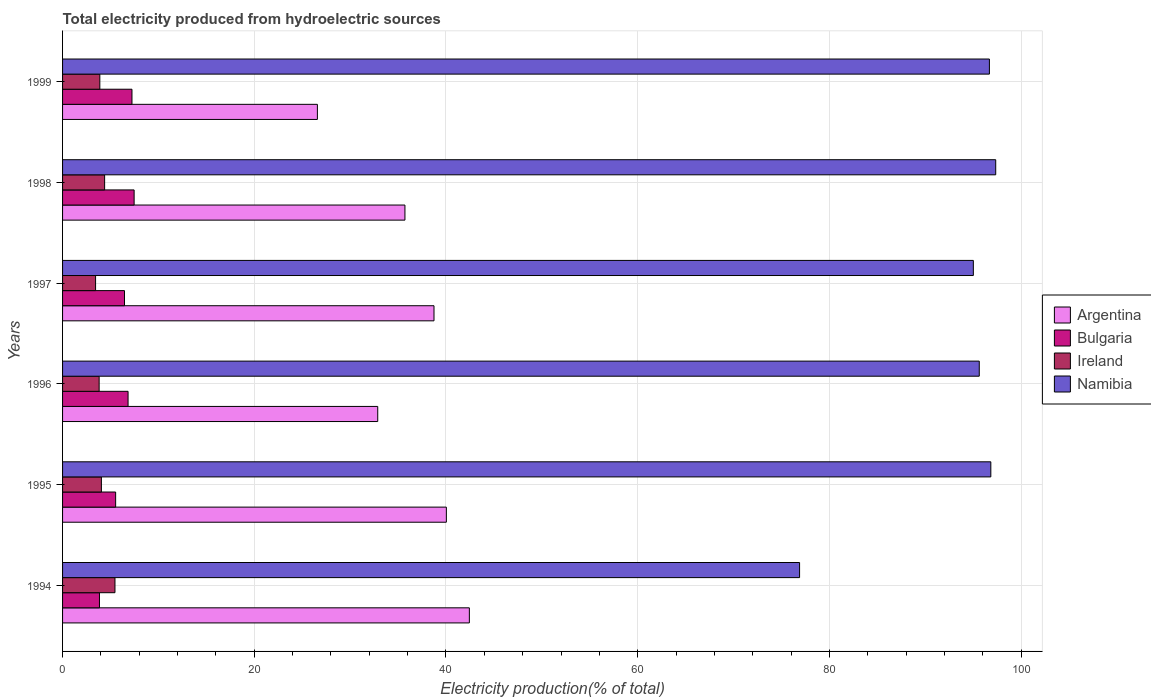How many different coloured bars are there?
Offer a very short reply. 4. How many groups of bars are there?
Your answer should be compact. 6. Are the number of bars on each tick of the Y-axis equal?
Your answer should be compact. Yes. How many bars are there on the 6th tick from the top?
Ensure brevity in your answer.  4. In how many cases, is the number of bars for a given year not equal to the number of legend labels?
Offer a very short reply. 0. What is the total electricity produced in Bulgaria in 1996?
Keep it short and to the point. 6.83. Across all years, what is the maximum total electricity produced in Argentina?
Your answer should be compact. 42.44. Across all years, what is the minimum total electricity produced in Ireland?
Offer a very short reply. 3.44. In which year was the total electricity produced in Argentina maximum?
Your response must be concise. 1994. What is the total total electricity produced in Namibia in the graph?
Keep it short and to the point. 558.42. What is the difference between the total electricity produced in Bulgaria in 1994 and that in 1997?
Give a very brief answer. -2.61. What is the difference between the total electricity produced in Ireland in 1997 and the total electricity produced in Argentina in 1999?
Offer a terse response. -23.14. What is the average total electricity produced in Namibia per year?
Make the answer very short. 93.07. In the year 1998, what is the difference between the total electricity produced in Ireland and total electricity produced in Bulgaria?
Ensure brevity in your answer.  -3.08. In how many years, is the total electricity produced in Ireland greater than 84 %?
Provide a succinct answer. 0. What is the ratio of the total electricity produced in Ireland in 1994 to that in 1998?
Keep it short and to the point. 1.25. What is the difference between the highest and the second highest total electricity produced in Bulgaria?
Your answer should be very brief. 0.22. What is the difference between the highest and the lowest total electricity produced in Bulgaria?
Your response must be concise. 3.62. In how many years, is the total electricity produced in Namibia greater than the average total electricity produced in Namibia taken over all years?
Your answer should be compact. 5. Is it the case that in every year, the sum of the total electricity produced in Ireland and total electricity produced in Argentina is greater than the sum of total electricity produced in Namibia and total electricity produced in Bulgaria?
Your answer should be compact. Yes. What does the 2nd bar from the top in 1996 represents?
Provide a succinct answer. Ireland. What does the 1st bar from the bottom in 1997 represents?
Offer a terse response. Argentina. Is it the case that in every year, the sum of the total electricity produced in Ireland and total electricity produced in Argentina is greater than the total electricity produced in Bulgaria?
Ensure brevity in your answer.  Yes. How many bars are there?
Provide a succinct answer. 24. What is the difference between two consecutive major ticks on the X-axis?
Offer a very short reply. 20. Does the graph contain grids?
Make the answer very short. Yes. Where does the legend appear in the graph?
Ensure brevity in your answer.  Center right. How are the legend labels stacked?
Your answer should be very brief. Vertical. What is the title of the graph?
Provide a succinct answer. Total electricity produced from hydroelectric sources. Does "Northern Mariana Islands" appear as one of the legend labels in the graph?
Make the answer very short. No. What is the Electricity production(% of total) in Argentina in 1994?
Make the answer very short. 42.44. What is the Electricity production(% of total) in Bulgaria in 1994?
Your response must be concise. 3.85. What is the Electricity production(% of total) of Ireland in 1994?
Provide a short and direct response. 5.47. What is the Electricity production(% of total) in Namibia in 1994?
Keep it short and to the point. 76.89. What is the Electricity production(% of total) in Argentina in 1995?
Keep it short and to the point. 40.04. What is the Electricity production(% of total) of Bulgaria in 1995?
Provide a short and direct response. 5.54. What is the Electricity production(% of total) in Ireland in 1995?
Provide a short and direct response. 4.05. What is the Electricity production(% of total) of Namibia in 1995?
Provide a short and direct response. 96.84. What is the Electricity production(% of total) of Argentina in 1996?
Ensure brevity in your answer.  32.88. What is the Electricity production(% of total) of Bulgaria in 1996?
Offer a very short reply. 6.83. What is the Electricity production(% of total) in Ireland in 1996?
Provide a short and direct response. 3.82. What is the Electricity production(% of total) of Namibia in 1996?
Provide a short and direct response. 95.63. What is the Electricity production(% of total) in Argentina in 1997?
Make the answer very short. 38.75. What is the Electricity production(% of total) in Bulgaria in 1997?
Provide a short and direct response. 6.46. What is the Electricity production(% of total) in Ireland in 1997?
Make the answer very short. 3.44. What is the Electricity production(% of total) in Namibia in 1997?
Keep it short and to the point. 95.02. What is the Electricity production(% of total) in Argentina in 1998?
Provide a succinct answer. 35.72. What is the Electricity production(% of total) in Bulgaria in 1998?
Your response must be concise. 7.47. What is the Electricity production(% of total) of Ireland in 1998?
Keep it short and to the point. 4.39. What is the Electricity production(% of total) of Namibia in 1998?
Ensure brevity in your answer.  97.35. What is the Electricity production(% of total) in Argentina in 1999?
Your answer should be compact. 26.58. What is the Electricity production(% of total) in Bulgaria in 1999?
Offer a very short reply. 7.24. What is the Electricity production(% of total) of Ireland in 1999?
Your response must be concise. 3.89. What is the Electricity production(% of total) of Namibia in 1999?
Provide a short and direct response. 96.69. Across all years, what is the maximum Electricity production(% of total) of Argentina?
Your answer should be very brief. 42.44. Across all years, what is the maximum Electricity production(% of total) of Bulgaria?
Keep it short and to the point. 7.47. Across all years, what is the maximum Electricity production(% of total) of Ireland?
Provide a short and direct response. 5.47. Across all years, what is the maximum Electricity production(% of total) of Namibia?
Offer a terse response. 97.35. Across all years, what is the minimum Electricity production(% of total) of Argentina?
Make the answer very short. 26.58. Across all years, what is the minimum Electricity production(% of total) of Bulgaria?
Give a very brief answer. 3.85. Across all years, what is the minimum Electricity production(% of total) of Ireland?
Your answer should be compact. 3.44. Across all years, what is the minimum Electricity production(% of total) of Namibia?
Keep it short and to the point. 76.89. What is the total Electricity production(% of total) in Argentina in the graph?
Make the answer very short. 216.41. What is the total Electricity production(% of total) in Bulgaria in the graph?
Your answer should be compact. 37.39. What is the total Electricity production(% of total) in Ireland in the graph?
Make the answer very short. 25.05. What is the total Electricity production(% of total) in Namibia in the graph?
Offer a terse response. 558.42. What is the difference between the Electricity production(% of total) in Argentina in 1994 and that in 1995?
Offer a very short reply. 2.4. What is the difference between the Electricity production(% of total) in Bulgaria in 1994 and that in 1995?
Offer a terse response. -1.69. What is the difference between the Electricity production(% of total) in Ireland in 1994 and that in 1995?
Your response must be concise. 1.42. What is the difference between the Electricity production(% of total) in Namibia in 1994 and that in 1995?
Give a very brief answer. -19.95. What is the difference between the Electricity production(% of total) in Argentina in 1994 and that in 1996?
Ensure brevity in your answer.  9.56. What is the difference between the Electricity production(% of total) of Bulgaria in 1994 and that in 1996?
Ensure brevity in your answer.  -2.98. What is the difference between the Electricity production(% of total) in Ireland in 1994 and that in 1996?
Make the answer very short. 1.65. What is the difference between the Electricity production(% of total) in Namibia in 1994 and that in 1996?
Offer a terse response. -18.74. What is the difference between the Electricity production(% of total) of Argentina in 1994 and that in 1997?
Ensure brevity in your answer.  3.69. What is the difference between the Electricity production(% of total) in Bulgaria in 1994 and that in 1997?
Your response must be concise. -2.61. What is the difference between the Electricity production(% of total) of Ireland in 1994 and that in 1997?
Your answer should be very brief. 2.02. What is the difference between the Electricity production(% of total) in Namibia in 1994 and that in 1997?
Your answer should be compact. -18.13. What is the difference between the Electricity production(% of total) in Argentina in 1994 and that in 1998?
Keep it short and to the point. 6.72. What is the difference between the Electricity production(% of total) of Bulgaria in 1994 and that in 1998?
Offer a terse response. -3.62. What is the difference between the Electricity production(% of total) in Ireland in 1994 and that in 1998?
Offer a very short reply. 1.08. What is the difference between the Electricity production(% of total) of Namibia in 1994 and that in 1998?
Provide a short and direct response. -20.46. What is the difference between the Electricity production(% of total) of Argentina in 1994 and that in 1999?
Provide a succinct answer. 15.85. What is the difference between the Electricity production(% of total) of Bulgaria in 1994 and that in 1999?
Give a very brief answer. -3.39. What is the difference between the Electricity production(% of total) in Ireland in 1994 and that in 1999?
Your answer should be compact. 1.58. What is the difference between the Electricity production(% of total) in Namibia in 1994 and that in 1999?
Give a very brief answer. -19.8. What is the difference between the Electricity production(% of total) in Argentina in 1995 and that in 1996?
Keep it short and to the point. 7.16. What is the difference between the Electricity production(% of total) of Bulgaria in 1995 and that in 1996?
Offer a very short reply. -1.3. What is the difference between the Electricity production(% of total) of Ireland in 1995 and that in 1996?
Offer a terse response. 0.23. What is the difference between the Electricity production(% of total) in Namibia in 1995 and that in 1996?
Provide a succinct answer. 1.21. What is the difference between the Electricity production(% of total) of Argentina in 1995 and that in 1997?
Ensure brevity in your answer.  1.29. What is the difference between the Electricity production(% of total) of Bulgaria in 1995 and that in 1997?
Offer a very short reply. -0.92. What is the difference between the Electricity production(% of total) of Ireland in 1995 and that in 1997?
Provide a succinct answer. 0.61. What is the difference between the Electricity production(% of total) in Namibia in 1995 and that in 1997?
Make the answer very short. 1.82. What is the difference between the Electricity production(% of total) in Argentina in 1995 and that in 1998?
Offer a terse response. 4.32. What is the difference between the Electricity production(% of total) of Bulgaria in 1995 and that in 1998?
Your response must be concise. -1.93. What is the difference between the Electricity production(% of total) in Ireland in 1995 and that in 1998?
Ensure brevity in your answer.  -0.34. What is the difference between the Electricity production(% of total) in Namibia in 1995 and that in 1998?
Your answer should be very brief. -0.51. What is the difference between the Electricity production(% of total) of Argentina in 1995 and that in 1999?
Offer a very short reply. 13.45. What is the difference between the Electricity production(% of total) in Bulgaria in 1995 and that in 1999?
Offer a terse response. -1.7. What is the difference between the Electricity production(% of total) in Ireland in 1995 and that in 1999?
Ensure brevity in your answer.  0.16. What is the difference between the Electricity production(% of total) in Namibia in 1995 and that in 1999?
Offer a very short reply. 0.15. What is the difference between the Electricity production(% of total) of Argentina in 1996 and that in 1997?
Make the answer very short. -5.87. What is the difference between the Electricity production(% of total) in Bulgaria in 1996 and that in 1997?
Ensure brevity in your answer.  0.37. What is the difference between the Electricity production(% of total) of Ireland in 1996 and that in 1997?
Give a very brief answer. 0.37. What is the difference between the Electricity production(% of total) in Namibia in 1996 and that in 1997?
Provide a short and direct response. 0.62. What is the difference between the Electricity production(% of total) in Argentina in 1996 and that in 1998?
Make the answer very short. -2.84. What is the difference between the Electricity production(% of total) in Bulgaria in 1996 and that in 1998?
Give a very brief answer. -0.63. What is the difference between the Electricity production(% of total) of Ireland in 1996 and that in 1998?
Your response must be concise. -0.57. What is the difference between the Electricity production(% of total) in Namibia in 1996 and that in 1998?
Your response must be concise. -1.72. What is the difference between the Electricity production(% of total) in Argentina in 1996 and that in 1999?
Keep it short and to the point. 6.29. What is the difference between the Electricity production(% of total) in Bulgaria in 1996 and that in 1999?
Offer a terse response. -0.41. What is the difference between the Electricity production(% of total) of Ireland in 1996 and that in 1999?
Your response must be concise. -0.07. What is the difference between the Electricity production(% of total) of Namibia in 1996 and that in 1999?
Keep it short and to the point. -1.06. What is the difference between the Electricity production(% of total) in Argentina in 1997 and that in 1998?
Provide a succinct answer. 3.03. What is the difference between the Electricity production(% of total) of Bulgaria in 1997 and that in 1998?
Your answer should be compact. -1. What is the difference between the Electricity production(% of total) in Ireland in 1997 and that in 1998?
Your answer should be very brief. -0.94. What is the difference between the Electricity production(% of total) in Namibia in 1997 and that in 1998?
Provide a short and direct response. -2.33. What is the difference between the Electricity production(% of total) of Argentina in 1997 and that in 1999?
Offer a very short reply. 12.16. What is the difference between the Electricity production(% of total) of Bulgaria in 1997 and that in 1999?
Provide a short and direct response. -0.78. What is the difference between the Electricity production(% of total) of Ireland in 1997 and that in 1999?
Provide a succinct answer. -0.44. What is the difference between the Electricity production(% of total) in Namibia in 1997 and that in 1999?
Provide a short and direct response. -1.68. What is the difference between the Electricity production(% of total) in Argentina in 1998 and that in 1999?
Provide a succinct answer. 9.13. What is the difference between the Electricity production(% of total) in Bulgaria in 1998 and that in 1999?
Offer a terse response. 0.22. What is the difference between the Electricity production(% of total) of Ireland in 1998 and that in 1999?
Provide a short and direct response. 0.5. What is the difference between the Electricity production(% of total) in Namibia in 1998 and that in 1999?
Provide a succinct answer. 0.66. What is the difference between the Electricity production(% of total) of Argentina in 1994 and the Electricity production(% of total) of Bulgaria in 1995?
Give a very brief answer. 36.9. What is the difference between the Electricity production(% of total) in Argentina in 1994 and the Electricity production(% of total) in Ireland in 1995?
Give a very brief answer. 38.39. What is the difference between the Electricity production(% of total) of Argentina in 1994 and the Electricity production(% of total) of Namibia in 1995?
Provide a succinct answer. -54.4. What is the difference between the Electricity production(% of total) in Bulgaria in 1994 and the Electricity production(% of total) in Ireland in 1995?
Your answer should be compact. -0.2. What is the difference between the Electricity production(% of total) of Bulgaria in 1994 and the Electricity production(% of total) of Namibia in 1995?
Offer a very short reply. -92.99. What is the difference between the Electricity production(% of total) of Ireland in 1994 and the Electricity production(% of total) of Namibia in 1995?
Ensure brevity in your answer.  -91.37. What is the difference between the Electricity production(% of total) in Argentina in 1994 and the Electricity production(% of total) in Bulgaria in 1996?
Ensure brevity in your answer.  35.61. What is the difference between the Electricity production(% of total) of Argentina in 1994 and the Electricity production(% of total) of Ireland in 1996?
Offer a terse response. 38.62. What is the difference between the Electricity production(% of total) of Argentina in 1994 and the Electricity production(% of total) of Namibia in 1996?
Provide a short and direct response. -53.19. What is the difference between the Electricity production(% of total) in Bulgaria in 1994 and the Electricity production(% of total) in Ireland in 1996?
Your answer should be very brief. 0.03. What is the difference between the Electricity production(% of total) of Bulgaria in 1994 and the Electricity production(% of total) of Namibia in 1996?
Provide a short and direct response. -91.78. What is the difference between the Electricity production(% of total) of Ireland in 1994 and the Electricity production(% of total) of Namibia in 1996?
Offer a very short reply. -90.17. What is the difference between the Electricity production(% of total) of Argentina in 1994 and the Electricity production(% of total) of Bulgaria in 1997?
Offer a terse response. 35.98. What is the difference between the Electricity production(% of total) in Argentina in 1994 and the Electricity production(% of total) in Ireland in 1997?
Offer a very short reply. 38.99. What is the difference between the Electricity production(% of total) in Argentina in 1994 and the Electricity production(% of total) in Namibia in 1997?
Provide a succinct answer. -52.58. What is the difference between the Electricity production(% of total) of Bulgaria in 1994 and the Electricity production(% of total) of Ireland in 1997?
Your response must be concise. 0.41. What is the difference between the Electricity production(% of total) of Bulgaria in 1994 and the Electricity production(% of total) of Namibia in 1997?
Ensure brevity in your answer.  -91.17. What is the difference between the Electricity production(% of total) of Ireland in 1994 and the Electricity production(% of total) of Namibia in 1997?
Make the answer very short. -89.55. What is the difference between the Electricity production(% of total) of Argentina in 1994 and the Electricity production(% of total) of Bulgaria in 1998?
Give a very brief answer. 34.97. What is the difference between the Electricity production(% of total) in Argentina in 1994 and the Electricity production(% of total) in Ireland in 1998?
Offer a very short reply. 38.05. What is the difference between the Electricity production(% of total) in Argentina in 1994 and the Electricity production(% of total) in Namibia in 1998?
Provide a succinct answer. -54.91. What is the difference between the Electricity production(% of total) in Bulgaria in 1994 and the Electricity production(% of total) in Ireland in 1998?
Make the answer very short. -0.54. What is the difference between the Electricity production(% of total) in Bulgaria in 1994 and the Electricity production(% of total) in Namibia in 1998?
Ensure brevity in your answer.  -93.5. What is the difference between the Electricity production(% of total) of Ireland in 1994 and the Electricity production(% of total) of Namibia in 1998?
Your answer should be compact. -91.88. What is the difference between the Electricity production(% of total) of Argentina in 1994 and the Electricity production(% of total) of Bulgaria in 1999?
Give a very brief answer. 35.2. What is the difference between the Electricity production(% of total) in Argentina in 1994 and the Electricity production(% of total) in Ireland in 1999?
Your response must be concise. 38.55. What is the difference between the Electricity production(% of total) in Argentina in 1994 and the Electricity production(% of total) in Namibia in 1999?
Make the answer very short. -54.25. What is the difference between the Electricity production(% of total) of Bulgaria in 1994 and the Electricity production(% of total) of Ireland in 1999?
Your answer should be compact. -0.04. What is the difference between the Electricity production(% of total) in Bulgaria in 1994 and the Electricity production(% of total) in Namibia in 1999?
Keep it short and to the point. -92.84. What is the difference between the Electricity production(% of total) of Ireland in 1994 and the Electricity production(% of total) of Namibia in 1999?
Keep it short and to the point. -91.22. What is the difference between the Electricity production(% of total) of Argentina in 1995 and the Electricity production(% of total) of Bulgaria in 1996?
Give a very brief answer. 33.21. What is the difference between the Electricity production(% of total) in Argentina in 1995 and the Electricity production(% of total) in Ireland in 1996?
Offer a terse response. 36.22. What is the difference between the Electricity production(% of total) in Argentina in 1995 and the Electricity production(% of total) in Namibia in 1996?
Keep it short and to the point. -55.59. What is the difference between the Electricity production(% of total) of Bulgaria in 1995 and the Electricity production(% of total) of Ireland in 1996?
Your answer should be very brief. 1.72. What is the difference between the Electricity production(% of total) of Bulgaria in 1995 and the Electricity production(% of total) of Namibia in 1996?
Your response must be concise. -90.1. What is the difference between the Electricity production(% of total) of Ireland in 1995 and the Electricity production(% of total) of Namibia in 1996?
Provide a succinct answer. -91.58. What is the difference between the Electricity production(% of total) in Argentina in 1995 and the Electricity production(% of total) in Bulgaria in 1997?
Your answer should be very brief. 33.58. What is the difference between the Electricity production(% of total) of Argentina in 1995 and the Electricity production(% of total) of Ireland in 1997?
Your response must be concise. 36.6. What is the difference between the Electricity production(% of total) in Argentina in 1995 and the Electricity production(% of total) in Namibia in 1997?
Your response must be concise. -54.98. What is the difference between the Electricity production(% of total) in Bulgaria in 1995 and the Electricity production(% of total) in Ireland in 1997?
Offer a very short reply. 2.09. What is the difference between the Electricity production(% of total) in Bulgaria in 1995 and the Electricity production(% of total) in Namibia in 1997?
Provide a short and direct response. -89.48. What is the difference between the Electricity production(% of total) of Ireland in 1995 and the Electricity production(% of total) of Namibia in 1997?
Your answer should be very brief. -90.97. What is the difference between the Electricity production(% of total) of Argentina in 1995 and the Electricity production(% of total) of Bulgaria in 1998?
Offer a terse response. 32.57. What is the difference between the Electricity production(% of total) of Argentina in 1995 and the Electricity production(% of total) of Ireland in 1998?
Your answer should be compact. 35.65. What is the difference between the Electricity production(% of total) of Argentina in 1995 and the Electricity production(% of total) of Namibia in 1998?
Your answer should be compact. -57.31. What is the difference between the Electricity production(% of total) in Bulgaria in 1995 and the Electricity production(% of total) in Ireland in 1998?
Your answer should be very brief. 1.15. What is the difference between the Electricity production(% of total) in Bulgaria in 1995 and the Electricity production(% of total) in Namibia in 1998?
Your answer should be very brief. -91.81. What is the difference between the Electricity production(% of total) in Ireland in 1995 and the Electricity production(% of total) in Namibia in 1998?
Give a very brief answer. -93.3. What is the difference between the Electricity production(% of total) in Argentina in 1995 and the Electricity production(% of total) in Bulgaria in 1999?
Provide a short and direct response. 32.8. What is the difference between the Electricity production(% of total) in Argentina in 1995 and the Electricity production(% of total) in Ireland in 1999?
Keep it short and to the point. 36.15. What is the difference between the Electricity production(% of total) of Argentina in 1995 and the Electricity production(% of total) of Namibia in 1999?
Ensure brevity in your answer.  -56.65. What is the difference between the Electricity production(% of total) in Bulgaria in 1995 and the Electricity production(% of total) in Ireland in 1999?
Keep it short and to the point. 1.65. What is the difference between the Electricity production(% of total) of Bulgaria in 1995 and the Electricity production(% of total) of Namibia in 1999?
Your answer should be compact. -91.15. What is the difference between the Electricity production(% of total) of Ireland in 1995 and the Electricity production(% of total) of Namibia in 1999?
Ensure brevity in your answer.  -92.64. What is the difference between the Electricity production(% of total) of Argentina in 1996 and the Electricity production(% of total) of Bulgaria in 1997?
Your answer should be compact. 26.42. What is the difference between the Electricity production(% of total) of Argentina in 1996 and the Electricity production(% of total) of Ireland in 1997?
Make the answer very short. 29.44. What is the difference between the Electricity production(% of total) in Argentina in 1996 and the Electricity production(% of total) in Namibia in 1997?
Your answer should be compact. -62.14. What is the difference between the Electricity production(% of total) of Bulgaria in 1996 and the Electricity production(% of total) of Ireland in 1997?
Your response must be concise. 3.39. What is the difference between the Electricity production(% of total) of Bulgaria in 1996 and the Electricity production(% of total) of Namibia in 1997?
Give a very brief answer. -88.18. What is the difference between the Electricity production(% of total) in Ireland in 1996 and the Electricity production(% of total) in Namibia in 1997?
Offer a very short reply. -91.2. What is the difference between the Electricity production(% of total) in Argentina in 1996 and the Electricity production(% of total) in Bulgaria in 1998?
Make the answer very short. 25.41. What is the difference between the Electricity production(% of total) of Argentina in 1996 and the Electricity production(% of total) of Ireland in 1998?
Provide a succinct answer. 28.49. What is the difference between the Electricity production(% of total) in Argentina in 1996 and the Electricity production(% of total) in Namibia in 1998?
Give a very brief answer. -64.47. What is the difference between the Electricity production(% of total) in Bulgaria in 1996 and the Electricity production(% of total) in Ireland in 1998?
Make the answer very short. 2.45. What is the difference between the Electricity production(% of total) in Bulgaria in 1996 and the Electricity production(% of total) in Namibia in 1998?
Keep it short and to the point. -90.52. What is the difference between the Electricity production(% of total) of Ireland in 1996 and the Electricity production(% of total) of Namibia in 1998?
Your answer should be compact. -93.53. What is the difference between the Electricity production(% of total) of Argentina in 1996 and the Electricity production(% of total) of Bulgaria in 1999?
Ensure brevity in your answer.  25.64. What is the difference between the Electricity production(% of total) in Argentina in 1996 and the Electricity production(% of total) in Ireland in 1999?
Provide a short and direct response. 28.99. What is the difference between the Electricity production(% of total) in Argentina in 1996 and the Electricity production(% of total) in Namibia in 1999?
Offer a terse response. -63.81. What is the difference between the Electricity production(% of total) in Bulgaria in 1996 and the Electricity production(% of total) in Ireland in 1999?
Provide a short and direct response. 2.95. What is the difference between the Electricity production(% of total) in Bulgaria in 1996 and the Electricity production(% of total) in Namibia in 1999?
Give a very brief answer. -89.86. What is the difference between the Electricity production(% of total) in Ireland in 1996 and the Electricity production(% of total) in Namibia in 1999?
Your answer should be compact. -92.88. What is the difference between the Electricity production(% of total) of Argentina in 1997 and the Electricity production(% of total) of Bulgaria in 1998?
Keep it short and to the point. 31.28. What is the difference between the Electricity production(% of total) in Argentina in 1997 and the Electricity production(% of total) in Ireland in 1998?
Keep it short and to the point. 34.36. What is the difference between the Electricity production(% of total) in Argentina in 1997 and the Electricity production(% of total) in Namibia in 1998?
Give a very brief answer. -58.6. What is the difference between the Electricity production(% of total) in Bulgaria in 1997 and the Electricity production(% of total) in Ireland in 1998?
Offer a terse response. 2.07. What is the difference between the Electricity production(% of total) of Bulgaria in 1997 and the Electricity production(% of total) of Namibia in 1998?
Give a very brief answer. -90.89. What is the difference between the Electricity production(% of total) of Ireland in 1997 and the Electricity production(% of total) of Namibia in 1998?
Offer a very short reply. -93.91. What is the difference between the Electricity production(% of total) in Argentina in 1997 and the Electricity production(% of total) in Bulgaria in 1999?
Your response must be concise. 31.51. What is the difference between the Electricity production(% of total) of Argentina in 1997 and the Electricity production(% of total) of Ireland in 1999?
Keep it short and to the point. 34.86. What is the difference between the Electricity production(% of total) of Argentina in 1997 and the Electricity production(% of total) of Namibia in 1999?
Offer a very short reply. -57.94. What is the difference between the Electricity production(% of total) in Bulgaria in 1997 and the Electricity production(% of total) in Ireland in 1999?
Provide a short and direct response. 2.57. What is the difference between the Electricity production(% of total) in Bulgaria in 1997 and the Electricity production(% of total) in Namibia in 1999?
Provide a succinct answer. -90.23. What is the difference between the Electricity production(% of total) in Ireland in 1997 and the Electricity production(% of total) in Namibia in 1999?
Ensure brevity in your answer.  -93.25. What is the difference between the Electricity production(% of total) in Argentina in 1998 and the Electricity production(% of total) in Bulgaria in 1999?
Offer a terse response. 28.48. What is the difference between the Electricity production(% of total) in Argentina in 1998 and the Electricity production(% of total) in Ireland in 1999?
Offer a very short reply. 31.83. What is the difference between the Electricity production(% of total) of Argentina in 1998 and the Electricity production(% of total) of Namibia in 1999?
Your response must be concise. -60.97. What is the difference between the Electricity production(% of total) of Bulgaria in 1998 and the Electricity production(% of total) of Ireland in 1999?
Provide a short and direct response. 3.58. What is the difference between the Electricity production(% of total) of Bulgaria in 1998 and the Electricity production(% of total) of Namibia in 1999?
Your answer should be very brief. -89.23. What is the difference between the Electricity production(% of total) in Ireland in 1998 and the Electricity production(% of total) in Namibia in 1999?
Your response must be concise. -92.3. What is the average Electricity production(% of total) of Argentina per year?
Your answer should be very brief. 36.07. What is the average Electricity production(% of total) of Bulgaria per year?
Give a very brief answer. 6.23. What is the average Electricity production(% of total) of Ireland per year?
Offer a very short reply. 4.18. What is the average Electricity production(% of total) of Namibia per year?
Make the answer very short. 93.07. In the year 1994, what is the difference between the Electricity production(% of total) in Argentina and Electricity production(% of total) in Bulgaria?
Keep it short and to the point. 38.59. In the year 1994, what is the difference between the Electricity production(% of total) of Argentina and Electricity production(% of total) of Ireland?
Your answer should be compact. 36.97. In the year 1994, what is the difference between the Electricity production(% of total) of Argentina and Electricity production(% of total) of Namibia?
Keep it short and to the point. -34.45. In the year 1994, what is the difference between the Electricity production(% of total) in Bulgaria and Electricity production(% of total) in Ireland?
Provide a short and direct response. -1.62. In the year 1994, what is the difference between the Electricity production(% of total) in Bulgaria and Electricity production(% of total) in Namibia?
Your answer should be compact. -73.04. In the year 1994, what is the difference between the Electricity production(% of total) of Ireland and Electricity production(% of total) of Namibia?
Provide a short and direct response. -71.42. In the year 1995, what is the difference between the Electricity production(% of total) in Argentina and Electricity production(% of total) in Bulgaria?
Give a very brief answer. 34.5. In the year 1995, what is the difference between the Electricity production(% of total) of Argentina and Electricity production(% of total) of Ireland?
Keep it short and to the point. 35.99. In the year 1995, what is the difference between the Electricity production(% of total) of Argentina and Electricity production(% of total) of Namibia?
Provide a short and direct response. -56.8. In the year 1995, what is the difference between the Electricity production(% of total) of Bulgaria and Electricity production(% of total) of Ireland?
Offer a terse response. 1.49. In the year 1995, what is the difference between the Electricity production(% of total) in Bulgaria and Electricity production(% of total) in Namibia?
Provide a succinct answer. -91.3. In the year 1995, what is the difference between the Electricity production(% of total) in Ireland and Electricity production(% of total) in Namibia?
Make the answer very short. -92.79. In the year 1996, what is the difference between the Electricity production(% of total) of Argentina and Electricity production(% of total) of Bulgaria?
Ensure brevity in your answer.  26.05. In the year 1996, what is the difference between the Electricity production(% of total) in Argentina and Electricity production(% of total) in Ireland?
Offer a very short reply. 29.06. In the year 1996, what is the difference between the Electricity production(% of total) of Argentina and Electricity production(% of total) of Namibia?
Give a very brief answer. -62.75. In the year 1996, what is the difference between the Electricity production(% of total) in Bulgaria and Electricity production(% of total) in Ireland?
Offer a terse response. 3.02. In the year 1996, what is the difference between the Electricity production(% of total) in Bulgaria and Electricity production(% of total) in Namibia?
Offer a very short reply. -88.8. In the year 1996, what is the difference between the Electricity production(% of total) in Ireland and Electricity production(% of total) in Namibia?
Your answer should be compact. -91.82. In the year 1997, what is the difference between the Electricity production(% of total) in Argentina and Electricity production(% of total) in Bulgaria?
Give a very brief answer. 32.29. In the year 1997, what is the difference between the Electricity production(% of total) of Argentina and Electricity production(% of total) of Ireland?
Your answer should be very brief. 35.31. In the year 1997, what is the difference between the Electricity production(% of total) in Argentina and Electricity production(% of total) in Namibia?
Your answer should be very brief. -56.27. In the year 1997, what is the difference between the Electricity production(% of total) of Bulgaria and Electricity production(% of total) of Ireland?
Ensure brevity in your answer.  3.02. In the year 1997, what is the difference between the Electricity production(% of total) of Bulgaria and Electricity production(% of total) of Namibia?
Give a very brief answer. -88.55. In the year 1997, what is the difference between the Electricity production(% of total) in Ireland and Electricity production(% of total) in Namibia?
Your response must be concise. -91.57. In the year 1998, what is the difference between the Electricity production(% of total) of Argentina and Electricity production(% of total) of Bulgaria?
Provide a short and direct response. 28.25. In the year 1998, what is the difference between the Electricity production(% of total) in Argentina and Electricity production(% of total) in Ireland?
Make the answer very short. 31.33. In the year 1998, what is the difference between the Electricity production(% of total) of Argentina and Electricity production(% of total) of Namibia?
Ensure brevity in your answer.  -61.63. In the year 1998, what is the difference between the Electricity production(% of total) of Bulgaria and Electricity production(% of total) of Ireland?
Give a very brief answer. 3.08. In the year 1998, what is the difference between the Electricity production(% of total) of Bulgaria and Electricity production(% of total) of Namibia?
Your answer should be compact. -89.88. In the year 1998, what is the difference between the Electricity production(% of total) in Ireland and Electricity production(% of total) in Namibia?
Make the answer very short. -92.96. In the year 1999, what is the difference between the Electricity production(% of total) of Argentina and Electricity production(% of total) of Bulgaria?
Provide a short and direct response. 19.34. In the year 1999, what is the difference between the Electricity production(% of total) of Argentina and Electricity production(% of total) of Ireland?
Offer a very short reply. 22.7. In the year 1999, what is the difference between the Electricity production(% of total) in Argentina and Electricity production(% of total) in Namibia?
Your response must be concise. -70.11. In the year 1999, what is the difference between the Electricity production(% of total) of Bulgaria and Electricity production(% of total) of Ireland?
Keep it short and to the point. 3.35. In the year 1999, what is the difference between the Electricity production(% of total) in Bulgaria and Electricity production(% of total) in Namibia?
Make the answer very short. -89.45. In the year 1999, what is the difference between the Electricity production(% of total) in Ireland and Electricity production(% of total) in Namibia?
Provide a short and direct response. -92.8. What is the ratio of the Electricity production(% of total) in Argentina in 1994 to that in 1995?
Your answer should be very brief. 1.06. What is the ratio of the Electricity production(% of total) in Bulgaria in 1994 to that in 1995?
Your answer should be very brief. 0.7. What is the ratio of the Electricity production(% of total) in Ireland in 1994 to that in 1995?
Make the answer very short. 1.35. What is the ratio of the Electricity production(% of total) of Namibia in 1994 to that in 1995?
Provide a short and direct response. 0.79. What is the ratio of the Electricity production(% of total) of Argentina in 1994 to that in 1996?
Your answer should be very brief. 1.29. What is the ratio of the Electricity production(% of total) of Bulgaria in 1994 to that in 1996?
Ensure brevity in your answer.  0.56. What is the ratio of the Electricity production(% of total) of Ireland in 1994 to that in 1996?
Provide a short and direct response. 1.43. What is the ratio of the Electricity production(% of total) of Namibia in 1994 to that in 1996?
Provide a succinct answer. 0.8. What is the ratio of the Electricity production(% of total) of Argentina in 1994 to that in 1997?
Offer a terse response. 1.1. What is the ratio of the Electricity production(% of total) in Bulgaria in 1994 to that in 1997?
Your answer should be very brief. 0.6. What is the ratio of the Electricity production(% of total) in Ireland in 1994 to that in 1997?
Your response must be concise. 1.59. What is the ratio of the Electricity production(% of total) of Namibia in 1994 to that in 1997?
Offer a terse response. 0.81. What is the ratio of the Electricity production(% of total) of Argentina in 1994 to that in 1998?
Make the answer very short. 1.19. What is the ratio of the Electricity production(% of total) of Bulgaria in 1994 to that in 1998?
Provide a short and direct response. 0.52. What is the ratio of the Electricity production(% of total) of Ireland in 1994 to that in 1998?
Your response must be concise. 1.25. What is the ratio of the Electricity production(% of total) in Namibia in 1994 to that in 1998?
Offer a terse response. 0.79. What is the ratio of the Electricity production(% of total) of Argentina in 1994 to that in 1999?
Your answer should be compact. 1.6. What is the ratio of the Electricity production(% of total) in Bulgaria in 1994 to that in 1999?
Your answer should be compact. 0.53. What is the ratio of the Electricity production(% of total) in Ireland in 1994 to that in 1999?
Ensure brevity in your answer.  1.41. What is the ratio of the Electricity production(% of total) in Namibia in 1994 to that in 1999?
Keep it short and to the point. 0.8. What is the ratio of the Electricity production(% of total) of Argentina in 1995 to that in 1996?
Provide a succinct answer. 1.22. What is the ratio of the Electricity production(% of total) in Bulgaria in 1995 to that in 1996?
Your answer should be very brief. 0.81. What is the ratio of the Electricity production(% of total) of Ireland in 1995 to that in 1996?
Give a very brief answer. 1.06. What is the ratio of the Electricity production(% of total) in Namibia in 1995 to that in 1996?
Give a very brief answer. 1.01. What is the ratio of the Electricity production(% of total) of Bulgaria in 1995 to that in 1997?
Offer a very short reply. 0.86. What is the ratio of the Electricity production(% of total) of Ireland in 1995 to that in 1997?
Provide a short and direct response. 1.18. What is the ratio of the Electricity production(% of total) of Namibia in 1995 to that in 1997?
Give a very brief answer. 1.02. What is the ratio of the Electricity production(% of total) of Argentina in 1995 to that in 1998?
Your answer should be compact. 1.12. What is the ratio of the Electricity production(% of total) of Bulgaria in 1995 to that in 1998?
Offer a very short reply. 0.74. What is the ratio of the Electricity production(% of total) in Argentina in 1995 to that in 1999?
Your response must be concise. 1.51. What is the ratio of the Electricity production(% of total) in Bulgaria in 1995 to that in 1999?
Make the answer very short. 0.76. What is the ratio of the Electricity production(% of total) in Ireland in 1995 to that in 1999?
Your answer should be compact. 1.04. What is the ratio of the Electricity production(% of total) of Argentina in 1996 to that in 1997?
Ensure brevity in your answer.  0.85. What is the ratio of the Electricity production(% of total) in Bulgaria in 1996 to that in 1997?
Your response must be concise. 1.06. What is the ratio of the Electricity production(% of total) of Ireland in 1996 to that in 1997?
Offer a terse response. 1.11. What is the ratio of the Electricity production(% of total) of Argentina in 1996 to that in 1998?
Provide a succinct answer. 0.92. What is the ratio of the Electricity production(% of total) in Bulgaria in 1996 to that in 1998?
Keep it short and to the point. 0.92. What is the ratio of the Electricity production(% of total) of Ireland in 1996 to that in 1998?
Provide a succinct answer. 0.87. What is the ratio of the Electricity production(% of total) in Namibia in 1996 to that in 1998?
Your answer should be very brief. 0.98. What is the ratio of the Electricity production(% of total) in Argentina in 1996 to that in 1999?
Your answer should be compact. 1.24. What is the ratio of the Electricity production(% of total) in Bulgaria in 1996 to that in 1999?
Make the answer very short. 0.94. What is the ratio of the Electricity production(% of total) in Ireland in 1996 to that in 1999?
Provide a succinct answer. 0.98. What is the ratio of the Electricity production(% of total) of Namibia in 1996 to that in 1999?
Give a very brief answer. 0.99. What is the ratio of the Electricity production(% of total) of Argentina in 1997 to that in 1998?
Offer a very short reply. 1.08. What is the ratio of the Electricity production(% of total) of Bulgaria in 1997 to that in 1998?
Your response must be concise. 0.87. What is the ratio of the Electricity production(% of total) in Ireland in 1997 to that in 1998?
Offer a terse response. 0.78. What is the ratio of the Electricity production(% of total) of Argentina in 1997 to that in 1999?
Your answer should be very brief. 1.46. What is the ratio of the Electricity production(% of total) of Bulgaria in 1997 to that in 1999?
Offer a very short reply. 0.89. What is the ratio of the Electricity production(% of total) in Ireland in 1997 to that in 1999?
Provide a short and direct response. 0.89. What is the ratio of the Electricity production(% of total) of Namibia in 1997 to that in 1999?
Ensure brevity in your answer.  0.98. What is the ratio of the Electricity production(% of total) in Argentina in 1998 to that in 1999?
Your answer should be very brief. 1.34. What is the ratio of the Electricity production(% of total) in Bulgaria in 1998 to that in 1999?
Offer a very short reply. 1.03. What is the ratio of the Electricity production(% of total) of Ireland in 1998 to that in 1999?
Your response must be concise. 1.13. What is the ratio of the Electricity production(% of total) in Namibia in 1998 to that in 1999?
Offer a terse response. 1.01. What is the difference between the highest and the second highest Electricity production(% of total) in Argentina?
Provide a short and direct response. 2.4. What is the difference between the highest and the second highest Electricity production(% of total) of Bulgaria?
Make the answer very short. 0.22. What is the difference between the highest and the second highest Electricity production(% of total) in Ireland?
Your response must be concise. 1.08. What is the difference between the highest and the second highest Electricity production(% of total) in Namibia?
Ensure brevity in your answer.  0.51. What is the difference between the highest and the lowest Electricity production(% of total) in Argentina?
Give a very brief answer. 15.85. What is the difference between the highest and the lowest Electricity production(% of total) of Bulgaria?
Give a very brief answer. 3.62. What is the difference between the highest and the lowest Electricity production(% of total) of Ireland?
Provide a succinct answer. 2.02. What is the difference between the highest and the lowest Electricity production(% of total) of Namibia?
Offer a very short reply. 20.46. 